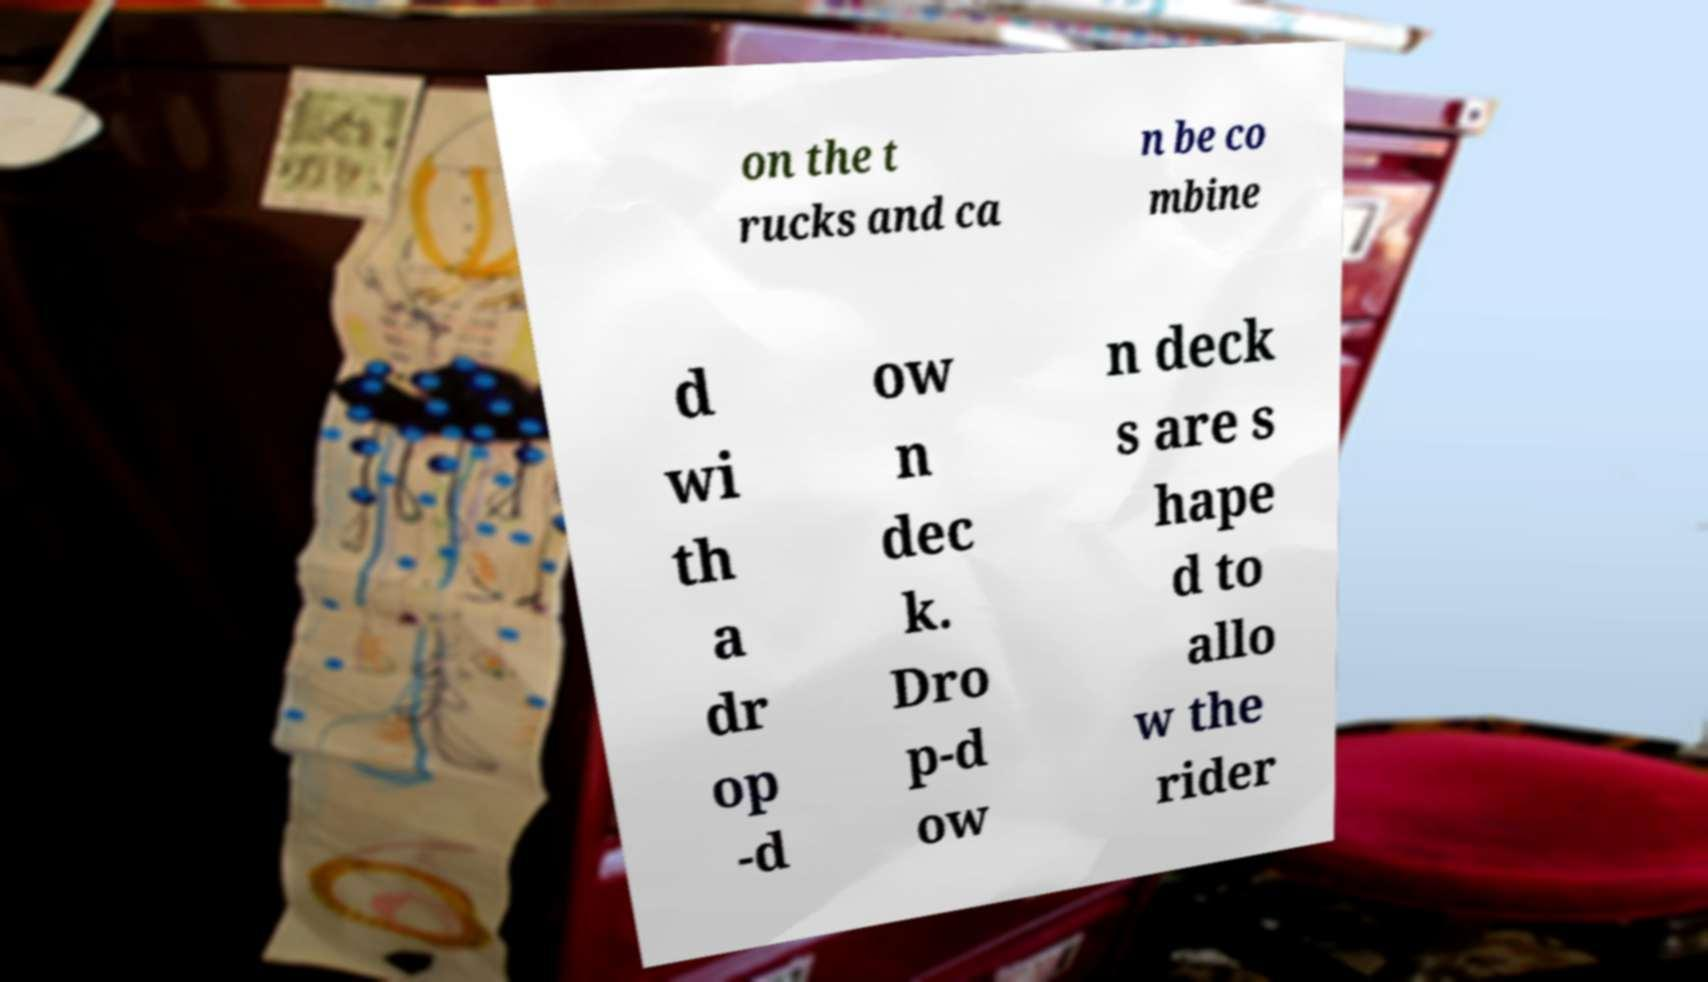What messages or text are displayed in this image? I need them in a readable, typed format. on the t rucks and ca n be co mbine d wi th a dr op -d ow n dec k. Dro p-d ow n deck s are s hape d to allo w the rider 